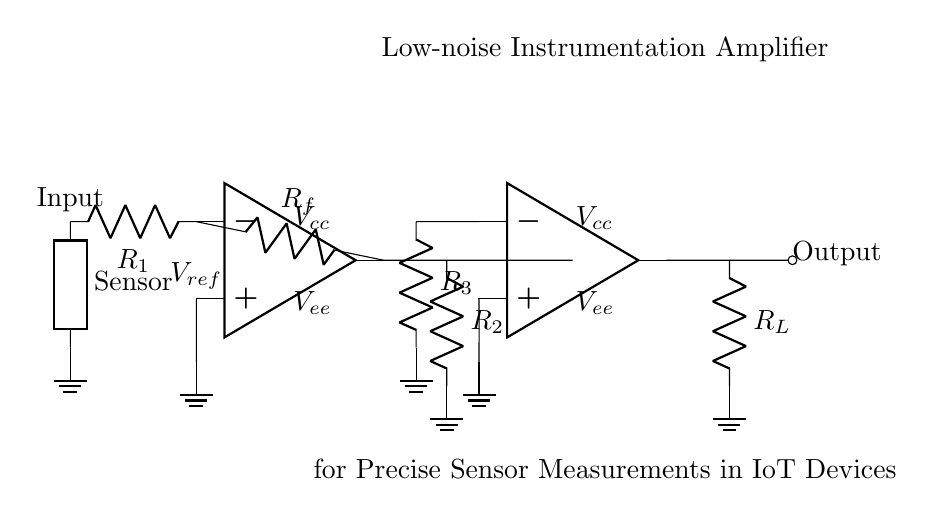What type of amplifier is shown in the circuit? The circuit diagram depicts a low-noise instrumentation amplifier, which is typically used for precise measurements. This is specified in the title of the circuit.
Answer: Low-noise instrumentation amplifier What is the purpose of the resistors R1, R2, R3? These resistors are used for setting the gain of the amplifier stages and for feedback purposes. R1 is involved in the input stage, while R2 and R3 are crucial for the second stage feedback configuration.
Answer: Gain adjustment What is the reference voltage labeled as in the circuit? The reference voltage is labeled as V_ref, which can be used to set the output level based on the input signal.
Answer: V_ref How many operational amplifiers are present in the circuit? There are two operational amplifiers used in this low-noise instrumentation amplifier setup, which can be identified as opamp1 and opamp2 in the diagram.
Answer: Two What is the function of the output load resistor, R_L? The load resistor R_L is used to provide a defined load to the output of the amplifier and helps determine the output voltage based on the current flowing through it.
Answer: Output load What is the main application of this type of amplifier? The circuit is specifically designed for precise sensor measurements within Internet of Things (IoT) devices, emphasizing accuracy and low noise in sensor data acquisition.
Answer: IoT sensor measurements How does the circuit reduce noise in sensor signals? The low-noise instrumentation amplifier configuration, along with careful component selection (like resistors), reduces common-mode noise and enhances signal fidelity, enabling more accurate measurements.
Answer: Noise reduction 